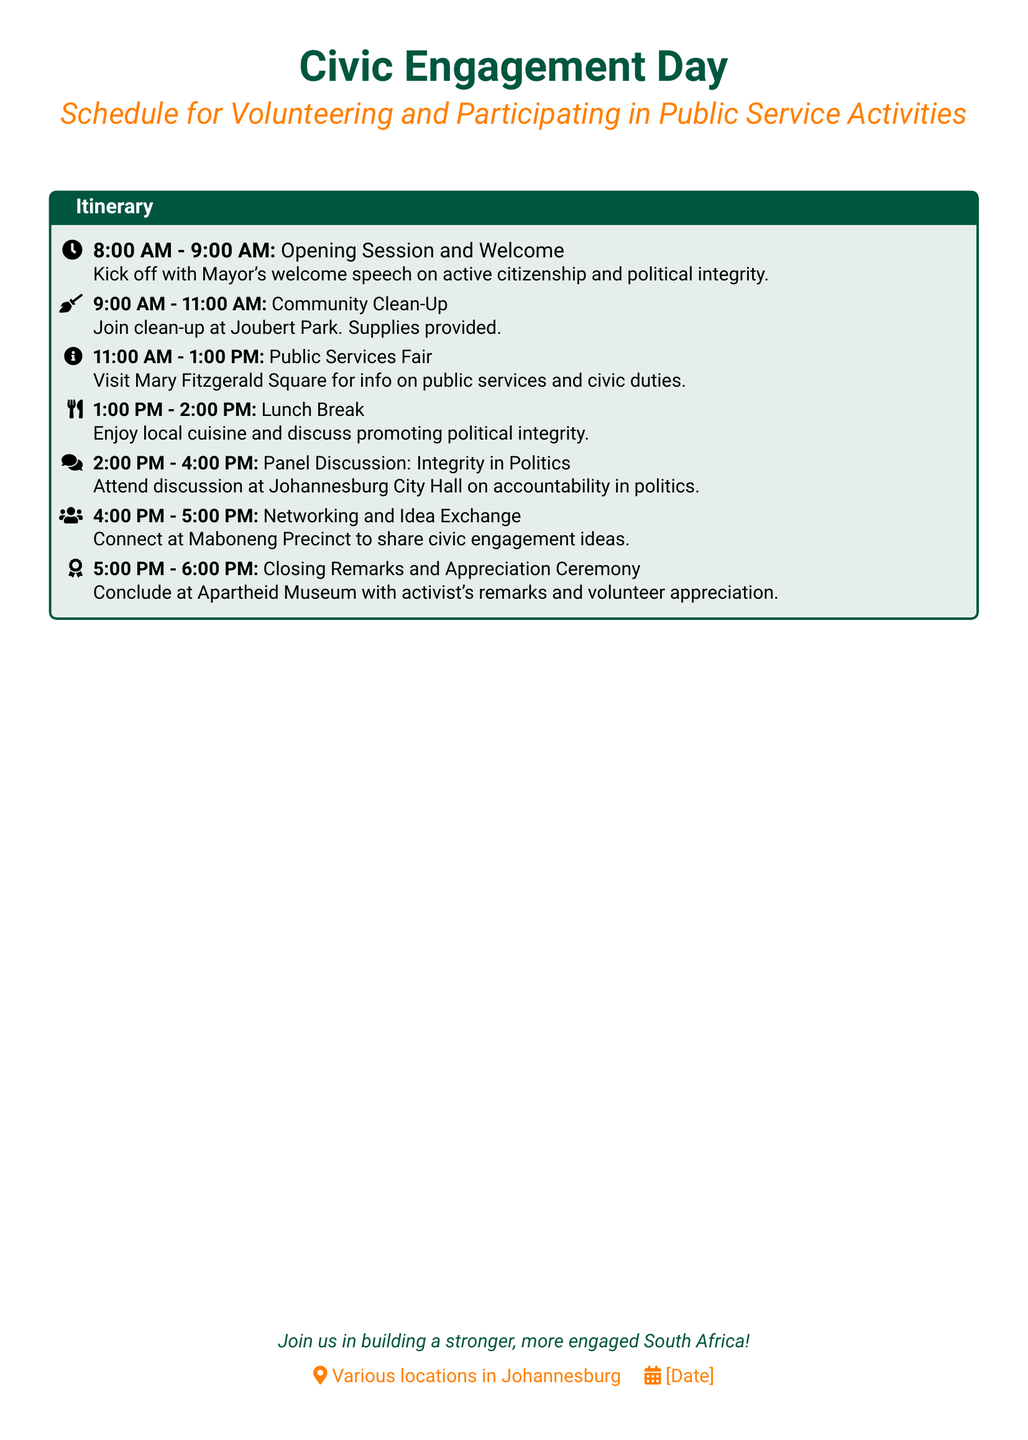What time does the opening session start? The opening session starts at 8:00 AM, as noted in the itinerary.
Answer: 8:00 AM How long is the community clean-up scheduled for? The community clean-up is scheduled for 2 hours, from 9:00 AM to 11:00 AM.
Answer: 2 hours Where will the public services fair take place? The public services fair will take place at Mary Fitzgerald Square, as indicated in the itinerary.
Answer: Mary Fitzgerald Square What is the main topic of the panel discussion? The main topic of the panel discussion is accountability in politics, as mentioned in the document.
Answer: Accountability in politics At what location will the closing remarks be held? The closing remarks will be held at the Apartheid Museum, as stated in the itinerary.
Answer: Apartheid Museum What activity follows the lunch break in the schedule? Following the lunch break, the next activity is the panel discussion on integrity in politics.
Answer: Panel Discussion: Integrity in Politics How long is the lunch break? The lunch break is scheduled for 1 hour, from 1:00 PM to 2:00 PM.
Answer: 1 hour What is the purpose of the networking session? The networking session aims for participants to share civic engagement ideas at Maboneng Precinct.
Answer: Share civic engagement ideas What message is conveyed in the closing statement? The closing statement encourages participation to build a stronger, more engaged South Africa.
Answer: Build a stronger, more engaged South Africa 